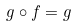Convert formula to latex. <formula><loc_0><loc_0><loc_500><loc_500>g \circ f = g</formula> 